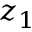Convert formula to latex. <formula><loc_0><loc_0><loc_500><loc_500>z _ { 1 }</formula> 